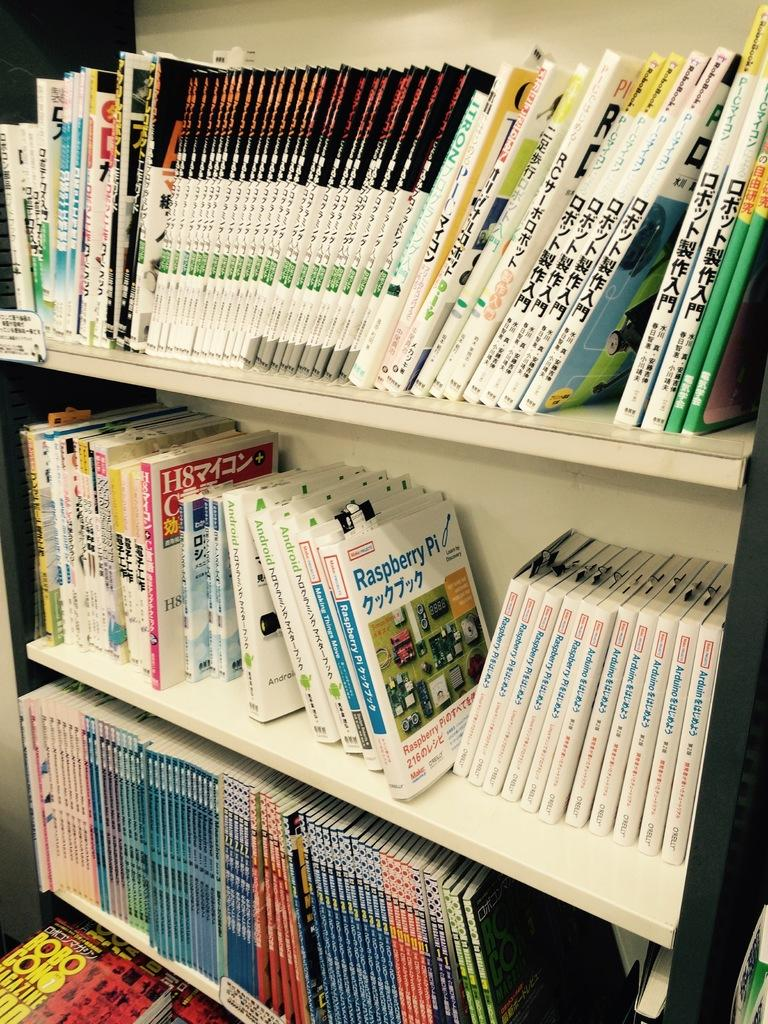<image>
Offer a succinct explanation of the picture presented. a shelf with many foreign books, one of them reads Raspberry Pi. 